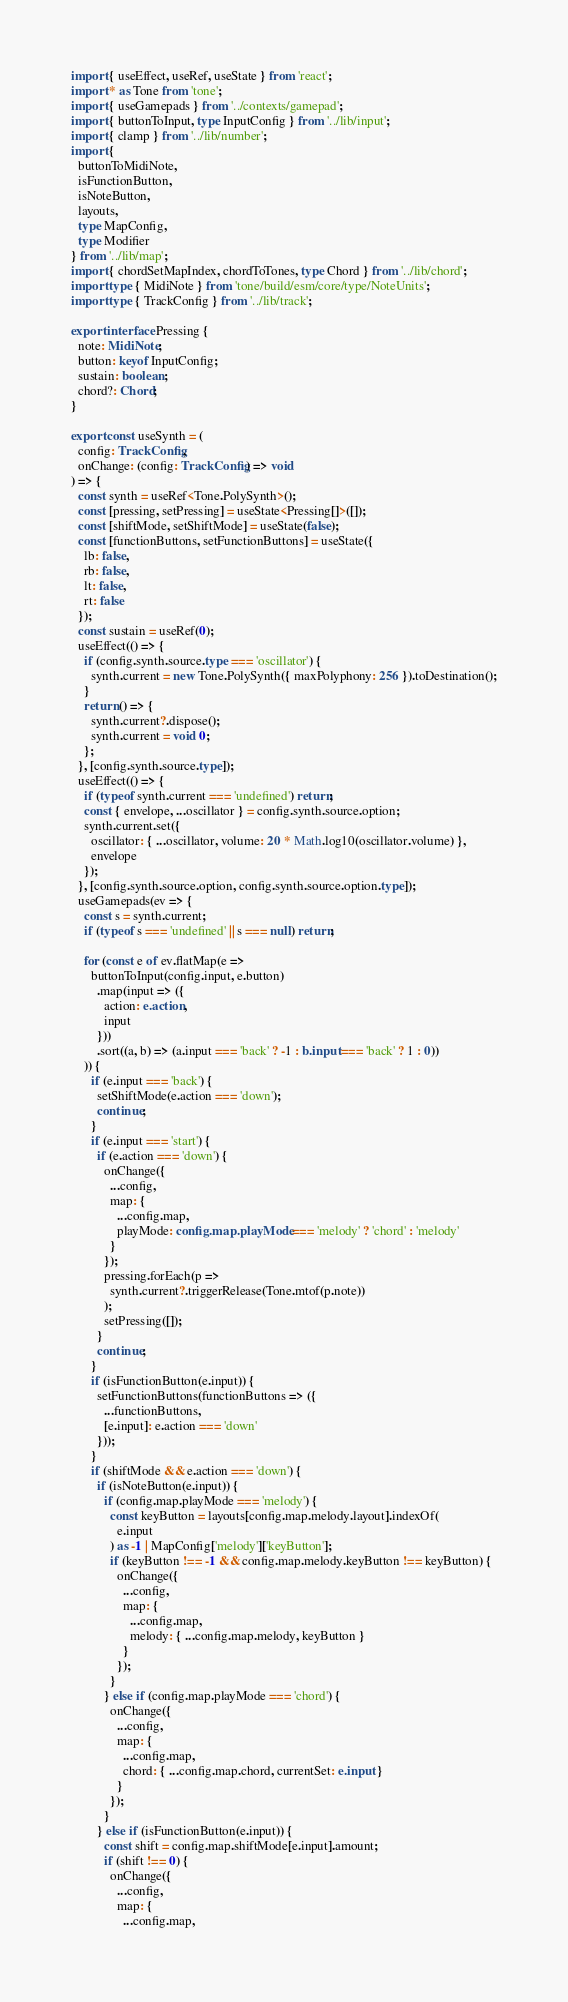<code> <loc_0><loc_0><loc_500><loc_500><_TypeScript_>import { useEffect, useRef, useState } from 'react';
import * as Tone from 'tone';
import { useGamepads } from '../contexts/gamepad';
import { buttonToInput, type InputConfig } from '../lib/input';
import { clamp } from '../lib/number';
import {
  buttonToMidiNote,
  isFunctionButton,
  isNoteButton,
  layouts,
  type MapConfig,
  type Modifier
} from '../lib/map';
import { chordSetMapIndex, chordToTones, type Chord } from '../lib/chord';
import type { MidiNote } from 'tone/build/esm/core/type/NoteUnits';
import type { TrackConfig } from '../lib/track';

export interface Pressing {
  note: MidiNote;
  button: keyof InputConfig;
  sustain: boolean;
  chord?: Chord;
}

export const useSynth = (
  config: TrackConfig,
  onChange: (config: TrackConfig) => void
) => {
  const synth = useRef<Tone.PolySynth>();
  const [pressing, setPressing] = useState<Pressing[]>([]);
  const [shiftMode, setShiftMode] = useState(false);
  const [functionButtons, setFunctionButtons] = useState({
    lb: false,
    rb: false,
    lt: false,
    rt: false
  });
  const sustain = useRef(0);
  useEffect(() => {
    if (config.synth.source.type === 'oscillator') {
      synth.current = new Tone.PolySynth({ maxPolyphony: 256 }).toDestination();
    }
    return () => {
      synth.current?.dispose();
      synth.current = void 0;
    };
  }, [config.synth.source.type]);
  useEffect(() => {
    if (typeof synth.current === 'undefined') return;
    const { envelope, ...oscillator } = config.synth.source.option;
    synth.current.set({
      oscillator: { ...oscillator, volume: 20 * Math.log10(oscillator.volume) },
      envelope
    });
  }, [config.synth.source.option, config.synth.source.option.type]);
  useGamepads(ev => {
    const s = synth.current;
    if (typeof s === 'undefined' || s === null) return;

    for (const e of ev.flatMap(e =>
      buttonToInput(config.input, e.button)
        .map(input => ({
          action: e.action,
          input
        }))
        .sort((a, b) => (a.input === 'back' ? -1 : b.input === 'back' ? 1 : 0))
    )) {
      if (e.input === 'back') {
        setShiftMode(e.action === 'down');
        continue;
      }
      if (e.input === 'start') {
        if (e.action === 'down') {
          onChange({
            ...config,
            map: {
              ...config.map,
              playMode: config.map.playMode === 'melody' ? 'chord' : 'melody'
            }
          });
          pressing.forEach(p =>
            synth.current?.triggerRelease(Tone.mtof(p.note))
          );
          setPressing([]);
        }
        continue;
      }
      if (isFunctionButton(e.input)) {
        setFunctionButtons(functionButtons => ({
          ...functionButtons,
          [e.input]: e.action === 'down'
        }));
      }
      if (shiftMode && e.action === 'down') {
        if (isNoteButton(e.input)) {
          if (config.map.playMode === 'melody') {
            const keyButton = layouts[config.map.melody.layout].indexOf(
              e.input
            ) as -1 | MapConfig['melody']['keyButton'];
            if (keyButton !== -1 && config.map.melody.keyButton !== keyButton) {
              onChange({
                ...config,
                map: {
                  ...config.map,
                  melody: { ...config.map.melody, keyButton }
                }
              });
            }
          } else if (config.map.playMode === 'chord') {
            onChange({
              ...config,
              map: {
                ...config.map,
                chord: { ...config.map.chord, currentSet: e.input }
              }
            });
          }
        } else if (isFunctionButton(e.input)) {
          const shift = config.map.shiftMode[e.input].amount;
          if (shift !== 0) {
            onChange({
              ...config,
              map: {
                ...config.map,</code> 